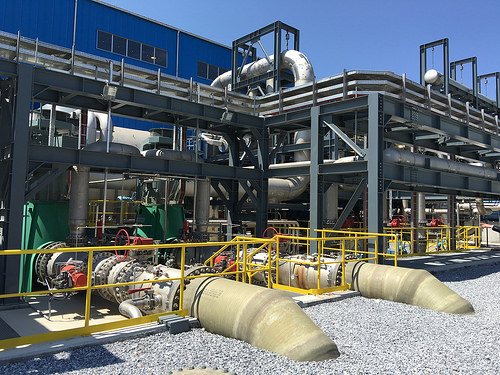<image>
Is the pipe under the window? Yes. The pipe is positioned underneath the window, with the window above it in the vertical space. 